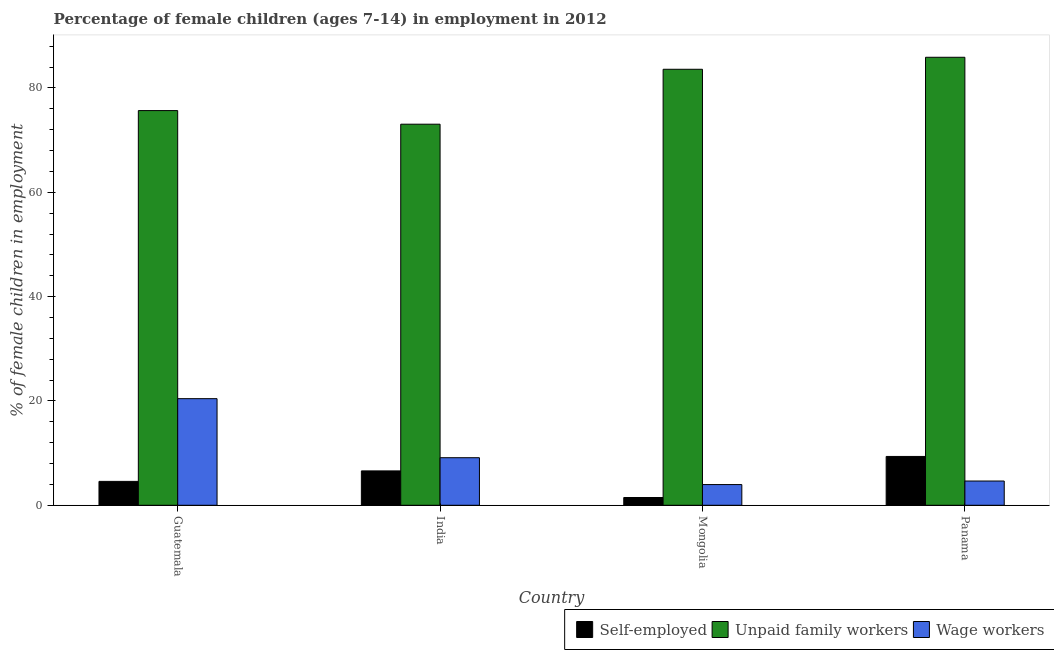How many different coloured bars are there?
Provide a short and direct response. 3. Are the number of bars on each tick of the X-axis equal?
Keep it short and to the point. Yes. How many bars are there on the 4th tick from the right?
Keep it short and to the point. 3. What is the label of the 1st group of bars from the left?
Offer a terse response. Guatemala. In how many cases, is the number of bars for a given country not equal to the number of legend labels?
Keep it short and to the point. 0. What is the percentage of children employed as wage workers in India?
Give a very brief answer. 9.12. Across all countries, what is the maximum percentage of children employed as unpaid family workers?
Provide a succinct answer. 85.89. Across all countries, what is the minimum percentage of children employed as unpaid family workers?
Your response must be concise. 73.06. In which country was the percentage of self employed children maximum?
Provide a short and direct response. Panama. In which country was the percentage of self employed children minimum?
Your response must be concise. Mongolia. What is the total percentage of self employed children in the graph?
Keep it short and to the point. 22.02. What is the difference between the percentage of children employed as wage workers in Guatemala and that in India?
Your answer should be compact. 11.32. What is the difference between the percentage of children employed as wage workers in Panama and the percentage of children employed as unpaid family workers in Mongolia?
Offer a very short reply. -78.94. What is the average percentage of self employed children per country?
Your response must be concise. 5.5. What is the difference between the percentage of children employed as unpaid family workers and percentage of self employed children in Mongolia?
Offer a terse response. 82.1. What is the ratio of the percentage of children employed as unpaid family workers in Guatemala to that in Panama?
Ensure brevity in your answer.  0.88. What is the difference between the highest and the second highest percentage of children employed as unpaid family workers?
Give a very brief answer. 2.3. What is the difference between the highest and the lowest percentage of children employed as wage workers?
Ensure brevity in your answer.  16.47. Is the sum of the percentage of children employed as unpaid family workers in India and Mongolia greater than the maximum percentage of self employed children across all countries?
Your answer should be compact. Yes. What does the 1st bar from the left in India represents?
Offer a very short reply. Self-employed. What does the 1st bar from the right in Mongolia represents?
Your answer should be compact. Wage workers. Is it the case that in every country, the sum of the percentage of self employed children and percentage of children employed as unpaid family workers is greater than the percentage of children employed as wage workers?
Keep it short and to the point. Yes. How many bars are there?
Keep it short and to the point. 12. Does the graph contain grids?
Provide a succinct answer. No. Where does the legend appear in the graph?
Keep it short and to the point. Bottom right. How many legend labels are there?
Offer a very short reply. 3. What is the title of the graph?
Offer a very short reply. Percentage of female children (ages 7-14) in employment in 2012. Does "Grants" appear as one of the legend labels in the graph?
Offer a very short reply. No. What is the label or title of the X-axis?
Give a very brief answer. Country. What is the label or title of the Y-axis?
Provide a succinct answer. % of female children in employment. What is the % of female children in employment of Self-employed in Guatemala?
Your answer should be very brief. 4.58. What is the % of female children in employment of Unpaid family workers in Guatemala?
Your answer should be very brief. 75.67. What is the % of female children in employment in Wage workers in Guatemala?
Keep it short and to the point. 20.44. What is the % of female children in employment in Self-employed in India?
Give a very brief answer. 6.59. What is the % of female children in employment in Unpaid family workers in India?
Your response must be concise. 73.06. What is the % of female children in employment of Wage workers in India?
Keep it short and to the point. 9.12. What is the % of female children in employment of Self-employed in Mongolia?
Ensure brevity in your answer.  1.49. What is the % of female children in employment in Unpaid family workers in Mongolia?
Keep it short and to the point. 83.59. What is the % of female children in employment of Wage workers in Mongolia?
Provide a short and direct response. 3.97. What is the % of female children in employment in Self-employed in Panama?
Your response must be concise. 9.36. What is the % of female children in employment of Unpaid family workers in Panama?
Keep it short and to the point. 85.89. What is the % of female children in employment in Wage workers in Panama?
Your answer should be compact. 4.65. Across all countries, what is the maximum % of female children in employment of Self-employed?
Your answer should be compact. 9.36. Across all countries, what is the maximum % of female children in employment of Unpaid family workers?
Provide a short and direct response. 85.89. Across all countries, what is the maximum % of female children in employment of Wage workers?
Make the answer very short. 20.44. Across all countries, what is the minimum % of female children in employment in Self-employed?
Ensure brevity in your answer.  1.49. Across all countries, what is the minimum % of female children in employment of Unpaid family workers?
Offer a very short reply. 73.06. Across all countries, what is the minimum % of female children in employment in Wage workers?
Make the answer very short. 3.97. What is the total % of female children in employment of Self-employed in the graph?
Provide a short and direct response. 22.02. What is the total % of female children in employment in Unpaid family workers in the graph?
Provide a succinct answer. 318.21. What is the total % of female children in employment of Wage workers in the graph?
Provide a succinct answer. 38.18. What is the difference between the % of female children in employment in Self-employed in Guatemala and that in India?
Ensure brevity in your answer.  -2.01. What is the difference between the % of female children in employment in Unpaid family workers in Guatemala and that in India?
Ensure brevity in your answer.  2.61. What is the difference between the % of female children in employment in Wage workers in Guatemala and that in India?
Your answer should be very brief. 11.32. What is the difference between the % of female children in employment in Self-employed in Guatemala and that in Mongolia?
Offer a very short reply. 3.09. What is the difference between the % of female children in employment in Unpaid family workers in Guatemala and that in Mongolia?
Your answer should be compact. -7.92. What is the difference between the % of female children in employment of Wage workers in Guatemala and that in Mongolia?
Offer a terse response. 16.47. What is the difference between the % of female children in employment in Self-employed in Guatemala and that in Panama?
Offer a very short reply. -4.78. What is the difference between the % of female children in employment of Unpaid family workers in Guatemala and that in Panama?
Your answer should be very brief. -10.22. What is the difference between the % of female children in employment of Wage workers in Guatemala and that in Panama?
Make the answer very short. 15.79. What is the difference between the % of female children in employment of Unpaid family workers in India and that in Mongolia?
Your answer should be compact. -10.53. What is the difference between the % of female children in employment in Wage workers in India and that in Mongolia?
Provide a short and direct response. 5.15. What is the difference between the % of female children in employment in Self-employed in India and that in Panama?
Your answer should be compact. -2.77. What is the difference between the % of female children in employment of Unpaid family workers in India and that in Panama?
Provide a succinct answer. -12.83. What is the difference between the % of female children in employment of Wage workers in India and that in Panama?
Your answer should be compact. 4.47. What is the difference between the % of female children in employment of Self-employed in Mongolia and that in Panama?
Your answer should be very brief. -7.87. What is the difference between the % of female children in employment in Unpaid family workers in Mongolia and that in Panama?
Your response must be concise. -2.3. What is the difference between the % of female children in employment of Wage workers in Mongolia and that in Panama?
Give a very brief answer. -0.68. What is the difference between the % of female children in employment in Self-employed in Guatemala and the % of female children in employment in Unpaid family workers in India?
Make the answer very short. -68.48. What is the difference between the % of female children in employment of Self-employed in Guatemala and the % of female children in employment of Wage workers in India?
Make the answer very short. -4.54. What is the difference between the % of female children in employment in Unpaid family workers in Guatemala and the % of female children in employment in Wage workers in India?
Your answer should be compact. 66.55. What is the difference between the % of female children in employment in Self-employed in Guatemala and the % of female children in employment in Unpaid family workers in Mongolia?
Provide a succinct answer. -79.01. What is the difference between the % of female children in employment in Self-employed in Guatemala and the % of female children in employment in Wage workers in Mongolia?
Offer a very short reply. 0.61. What is the difference between the % of female children in employment of Unpaid family workers in Guatemala and the % of female children in employment of Wage workers in Mongolia?
Your answer should be compact. 71.7. What is the difference between the % of female children in employment in Self-employed in Guatemala and the % of female children in employment in Unpaid family workers in Panama?
Your answer should be very brief. -81.31. What is the difference between the % of female children in employment of Self-employed in Guatemala and the % of female children in employment of Wage workers in Panama?
Offer a very short reply. -0.07. What is the difference between the % of female children in employment in Unpaid family workers in Guatemala and the % of female children in employment in Wage workers in Panama?
Make the answer very short. 71.02. What is the difference between the % of female children in employment in Self-employed in India and the % of female children in employment in Unpaid family workers in Mongolia?
Keep it short and to the point. -77. What is the difference between the % of female children in employment of Self-employed in India and the % of female children in employment of Wage workers in Mongolia?
Your answer should be very brief. 2.62. What is the difference between the % of female children in employment of Unpaid family workers in India and the % of female children in employment of Wage workers in Mongolia?
Give a very brief answer. 69.09. What is the difference between the % of female children in employment in Self-employed in India and the % of female children in employment in Unpaid family workers in Panama?
Offer a terse response. -79.3. What is the difference between the % of female children in employment in Self-employed in India and the % of female children in employment in Wage workers in Panama?
Provide a short and direct response. 1.94. What is the difference between the % of female children in employment of Unpaid family workers in India and the % of female children in employment of Wage workers in Panama?
Keep it short and to the point. 68.41. What is the difference between the % of female children in employment in Self-employed in Mongolia and the % of female children in employment in Unpaid family workers in Panama?
Offer a terse response. -84.4. What is the difference between the % of female children in employment in Self-employed in Mongolia and the % of female children in employment in Wage workers in Panama?
Keep it short and to the point. -3.16. What is the difference between the % of female children in employment of Unpaid family workers in Mongolia and the % of female children in employment of Wage workers in Panama?
Make the answer very short. 78.94. What is the average % of female children in employment of Self-employed per country?
Your answer should be compact. 5.5. What is the average % of female children in employment in Unpaid family workers per country?
Your answer should be very brief. 79.55. What is the average % of female children in employment in Wage workers per country?
Provide a succinct answer. 9.54. What is the difference between the % of female children in employment of Self-employed and % of female children in employment of Unpaid family workers in Guatemala?
Provide a succinct answer. -71.09. What is the difference between the % of female children in employment in Self-employed and % of female children in employment in Wage workers in Guatemala?
Provide a succinct answer. -15.86. What is the difference between the % of female children in employment of Unpaid family workers and % of female children in employment of Wage workers in Guatemala?
Your response must be concise. 55.23. What is the difference between the % of female children in employment of Self-employed and % of female children in employment of Unpaid family workers in India?
Give a very brief answer. -66.47. What is the difference between the % of female children in employment in Self-employed and % of female children in employment in Wage workers in India?
Offer a very short reply. -2.53. What is the difference between the % of female children in employment in Unpaid family workers and % of female children in employment in Wage workers in India?
Your answer should be very brief. 63.94. What is the difference between the % of female children in employment in Self-employed and % of female children in employment in Unpaid family workers in Mongolia?
Make the answer very short. -82.1. What is the difference between the % of female children in employment of Self-employed and % of female children in employment of Wage workers in Mongolia?
Offer a terse response. -2.48. What is the difference between the % of female children in employment of Unpaid family workers and % of female children in employment of Wage workers in Mongolia?
Keep it short and to the point. 79.62. What is the difference between the % of female children in employment of Self-employed and % of female children in employment of Unpaid family workers in Panama?
Offer a very short reply. -76.53. What is the difference between the % of female children in employment of Self-employed and % of female children in employment of Wage workers in Panama?
Ensure brevity in your answer.  4.71. What is the difference between the % of female children in employment in Unpaid family workers and % of female children in employment in Wage workers in Panama?
Offer a very short reply. 81.24. What is the ratio of the % of female children in employment in Self-employed in Guatemala to that in India?
Provide a short and direct response. 0.69. What is the ratio of the % of female children in employment of Unpaid family workers in Guatemala to that in India?
Offer a very short reply. 1.04. What is the ratio of the % of female children in employment of Wage workers in Guatemala to that in India?
Offer a terse response. 2.24. What is the ratio of the % of female children in employment in Self-employed in Guatemala to that in Mongolia?
Ensure brevity in your answer.  3.07. What is the ratio of the % of female children in employment in Unpaid family workers in Guatemala to that in Mongolia?
Keep it short and to the point. 0.91. What is the ratio of the % of female children in employment of Wage workers in Guatemala to that in Mongolia?
Offer a very short reply. 5.15. What is the ratio of the % of female children in employment of Self-employed in Guatemala to that in Panama?
Provide a short and direct response. 0.49. What is the ratio of the % of female children in employment of Unpaid family workers in Guatemala to that in Panama?
Make the answer very short. 0.88. What is the ratio of the % of female children in employment of Wage workers in Guatemala to that in Panama?
Offer a terse response. 4.4. What is the ratio of the % of female children in employment in Self-employed in India to that in Mongolia?
Your answer should be compact. 4.42. What is the ratio of the % of female children in employment in Unpaid family workers in India to that in Mongolia?
Provide a succinct answer. 0.87. What is the ratio of the % of female children in employment in Wage workers in India to that in Mongolia?
Your response must be concise. 2.3. What is the ratio of the % of female children in employment in Self-employed in India to that in Panama?
Make the answer very short. 0.7. What is the ratio of the % of female children in employment of Unpaid family workers in India to that in Panama?
Offer a very short reply. 0.85. What is the ratio of the % of female children in employment in Wage workers in India to that in Panama?
Offer a very short reply. 1.96. What is the ratio of the % of female children in employment of Self-employed in Mongolia to that in Panama?
Provide a short and direct response. 0.16. What is the ratio of the % of female children in employment of Unpaid family workers in Mongolia to that in Panama?
Offer a terse response. 0.97. What is the ratio of the % of female children in employment of Wage workers in Mongolia to that in Panama?
Give a very brief answer. 0.85. What is the difference between the highest and the second highest % of female children in employment of Self-employed?
Your answer should be very brief. 2.77. What is the difference between the highest and the second highest % of female children in employment in Unpaid family workers?
Offer a terse response. 2.3. What is the difference between the highest and the second highest % of female children in employment in Wage workers?
Ensure brevity in your answer.  11.32. What is the difference between the highest and the lowest % of female children in employment in Self-employed?
Keep it short and to the point. 7.87. What is the difference between the highest and the lowest % of female children in employment of Unpaid family workers?
Offer a very short reply. 12.83. What is the difference between the highest and the lowest % of female children in employment of Wage workers?
Your answer should be compact. 16.47. 